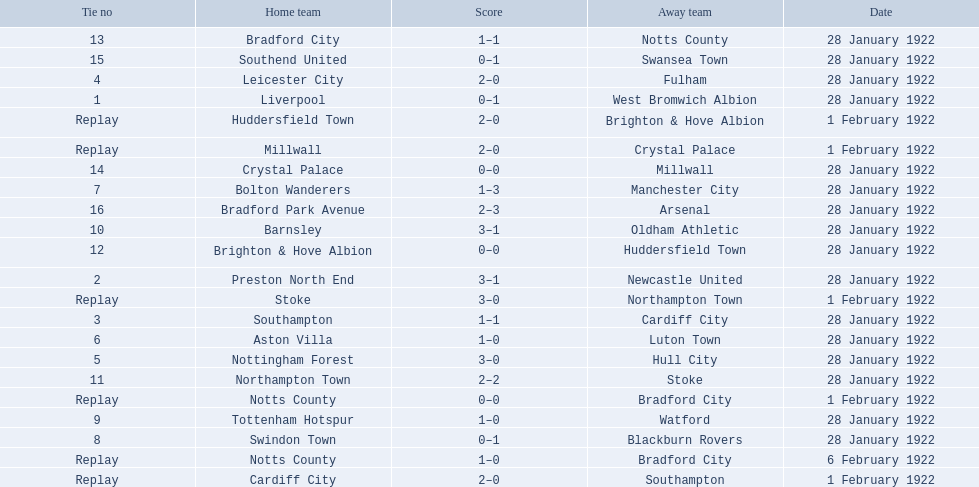What was the score in the aston villa game? 1–0. Which other team had an identical score? Tottenham Hotspur. 